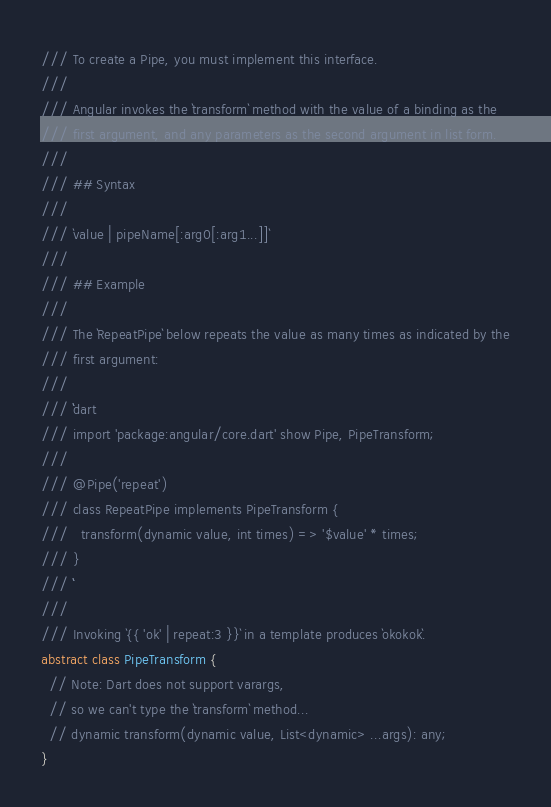<code> <loc_0><loc_0><loc_500><loc_500><_Dart_>/// To create a Pipe, you must implement this interface.
///
/// Angular invokes the `transform` method with the value of a binding as the
/// first argument, and any parameters as the second argument in list form.
///
/// ## Syntax
///
/// `value | pipeName[:arg0[:arg1...]]`
///
/// ## Example
///
/// The `RepeatPipe` below repeats the value as many times as indicated by the
/// first argument:
///
/// ```dart
/// import 'package:angular/core.dart' show Pipe, PipeTransform;
///
/// @Pipe('repeat')
/// class RepeatPipe implements PipeTransform {
///   transform(dynamic value, int times) => '$value' * times;
/// }
/// ```
///
/// Invoking `{{ 'ok' | repeat:3 }}` in a template produces `okokok`.
abstract class PipeTransform {
  // Note: Dart does not support varargs,
  // so we can't type the `transform` method...
  // dynamic transform(dynamic value, List<dynamic> ...args): any;
}
</code> 